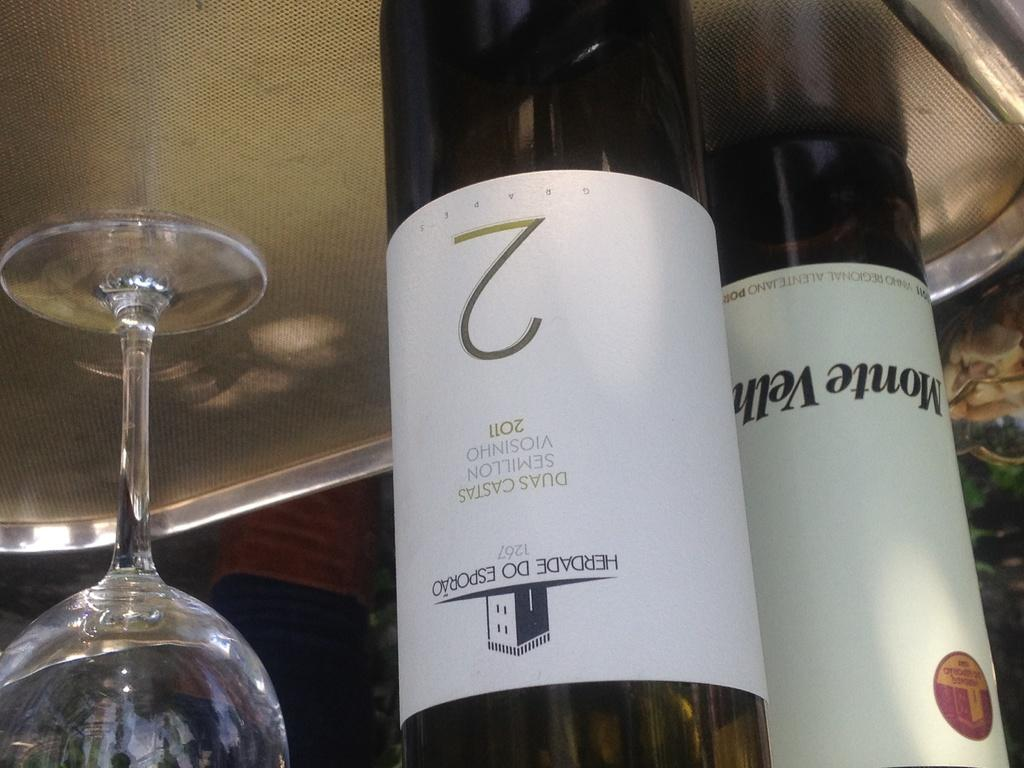What piece of furniture is present in the image? There is a table in the image. What is placed on the table? There is a tray and a wine glass on the table. Are there any other items related to wine on the table? Yes, there are wine bottles on the table. What type of dust can be seen on the table in the image? There is no dust visible on the table in the image. What shape is the table in the image? The shape of the table is not mentioned in the provided facts, so it cannot be determined from the image. 